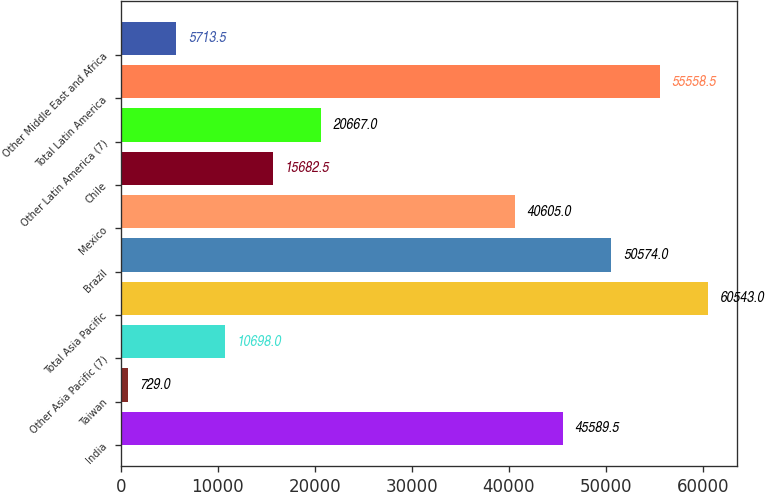Convert chart. <chart><loc_0><loc_0><loc_500><loc_500><bar_chart><fcel>India<fcel>Taiwan<fcel>Other Asia Pacific (7)<fcel>Total Asia Pacific<fcel>Brazil<fcel>Mexico<fcel>Chile<fcel>Other Latin America (7)<fcel>Total Latin America<fcel>Other Middle East and Africa<nl><fcel>45589.5<fcel>729<fcel>10698<fcel>60543<fcel>50574<fcel>40605<fcel>15682.5<fcel>20667<fcel>55558.5<fcel>5713.5<nl></chart> 